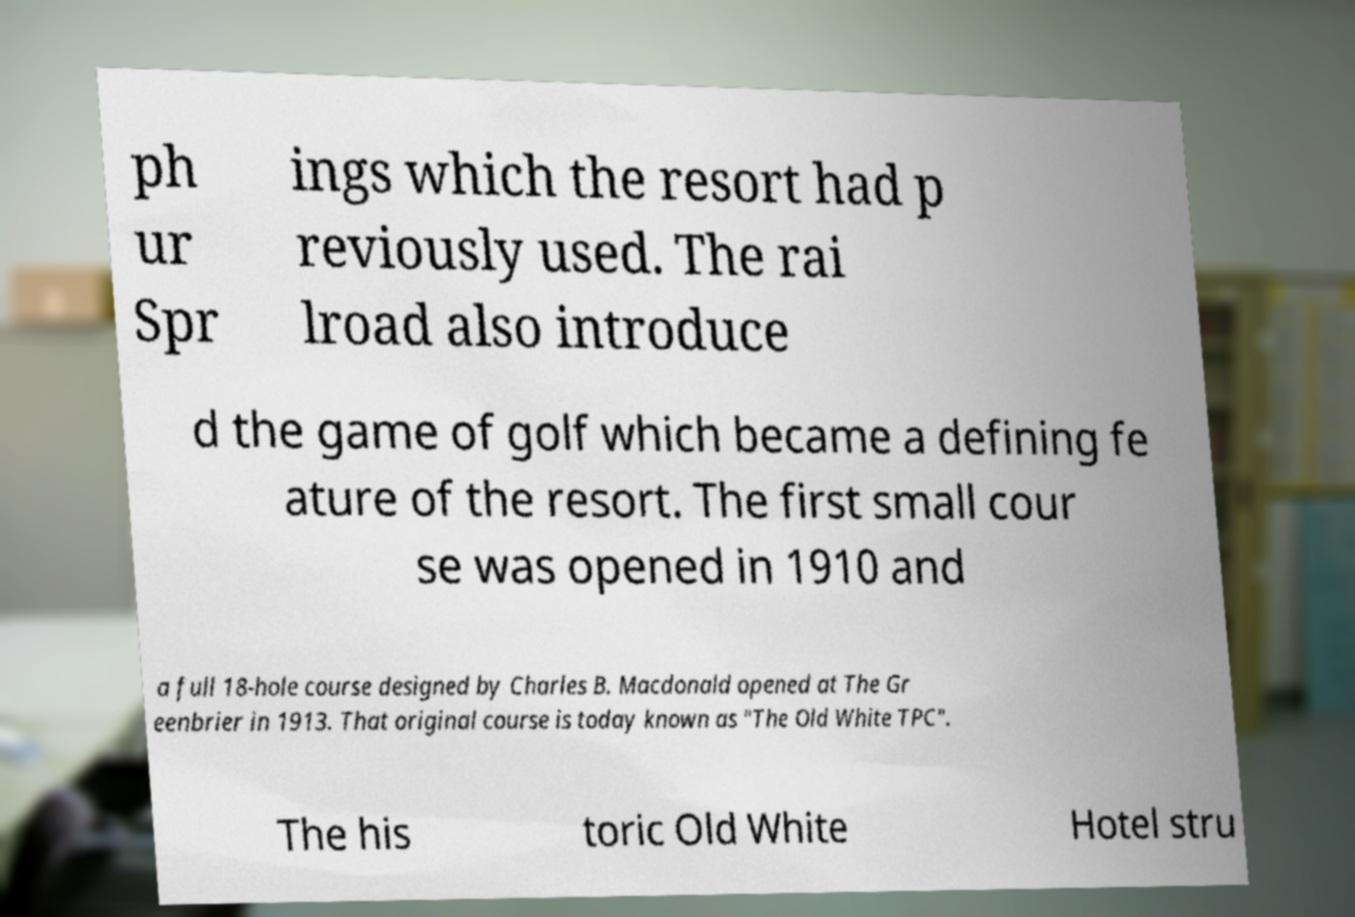I need the written content from this picture converted into text. Can you do that? ph ur Spr ings which the resort had p reviously used. The rai lroad also introduce d the game of golf which became a defining fe ature of the resort. The first small cour se was opened in 1910 and a full 18-hole course designed by Charles B. Macdonald opened at The Gr eenbrier in 1913. That original course is today known as "The Old White TPC". The his toric Old White Hotel stru 